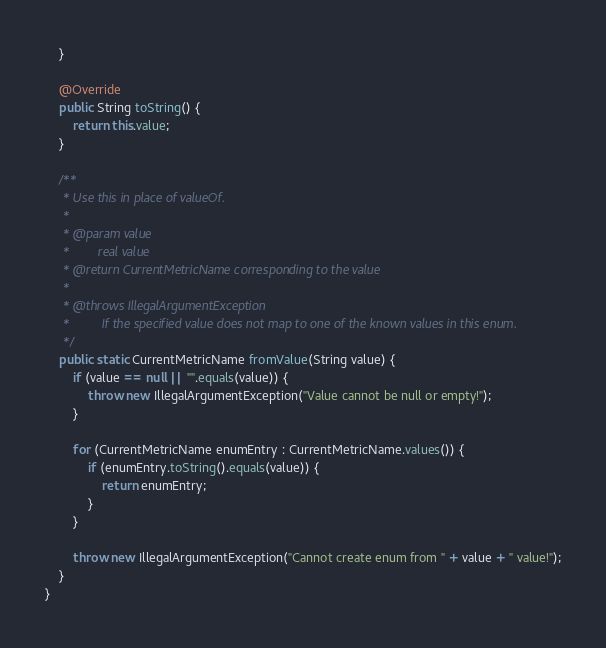Convert code to text. <code><loc_0><loc_0><loc_500><loc_500><_Java_>    }

    @Override
    public String toString() {
        return this.value;
    }

    /**
     * Use this in place of valueOf.
     *
     * @param value
     *        real value
     * @return CurrentMetricName corresponding to the value
     *
     * @throws IllegalArgumentException
     *         If the specified value does not map to one of the known values in this enum.
     */
    public static CurrentMetricName fromValue(String value) {
        if (value == null || "".equals(value)) {
            throw new IllegalArgumentException("Value cannot be null or empty!");
        }

        for (CurrentMetricName enumEntry : CurrentMetricName.values()) {
            if (enumEntry.toString().equals(value)) {
                return enumEntry;
            }
        }

        throw new IllegalArgumentException("Cannot create enum from " + value + " value!");
    }
}
</code> 